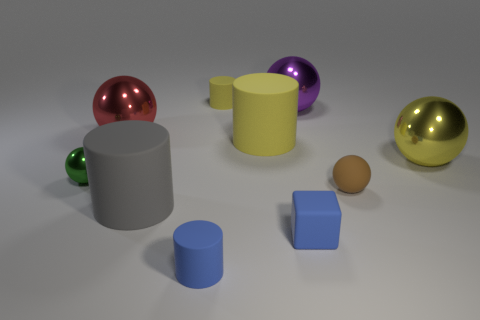Subtract all gray cylinders. How many cylinders are left? 3 Subtract all blue cylinders. How many cylinders are left? 3 Subtract 1 blocks. How many blocks are left? 0 Subtract all gray cylinders. Subtract all yellow cubes. How many cylinders are left? 3 Subtract all blue balls. How many gray cylinders are left? 1 Subtract all metallic balls. Subtract all blue matte cubes. How many objects are left? 5 Add 4 small brown matte objects. How many small brown matte objects are left? 5 Add 8 tiny blue matte cylinders. How many tiny blue matte cylinders exist? 9 Subtract 0 green cubes. How many objects are left? 10 Subtract all blocks. How many objects are left? 9 